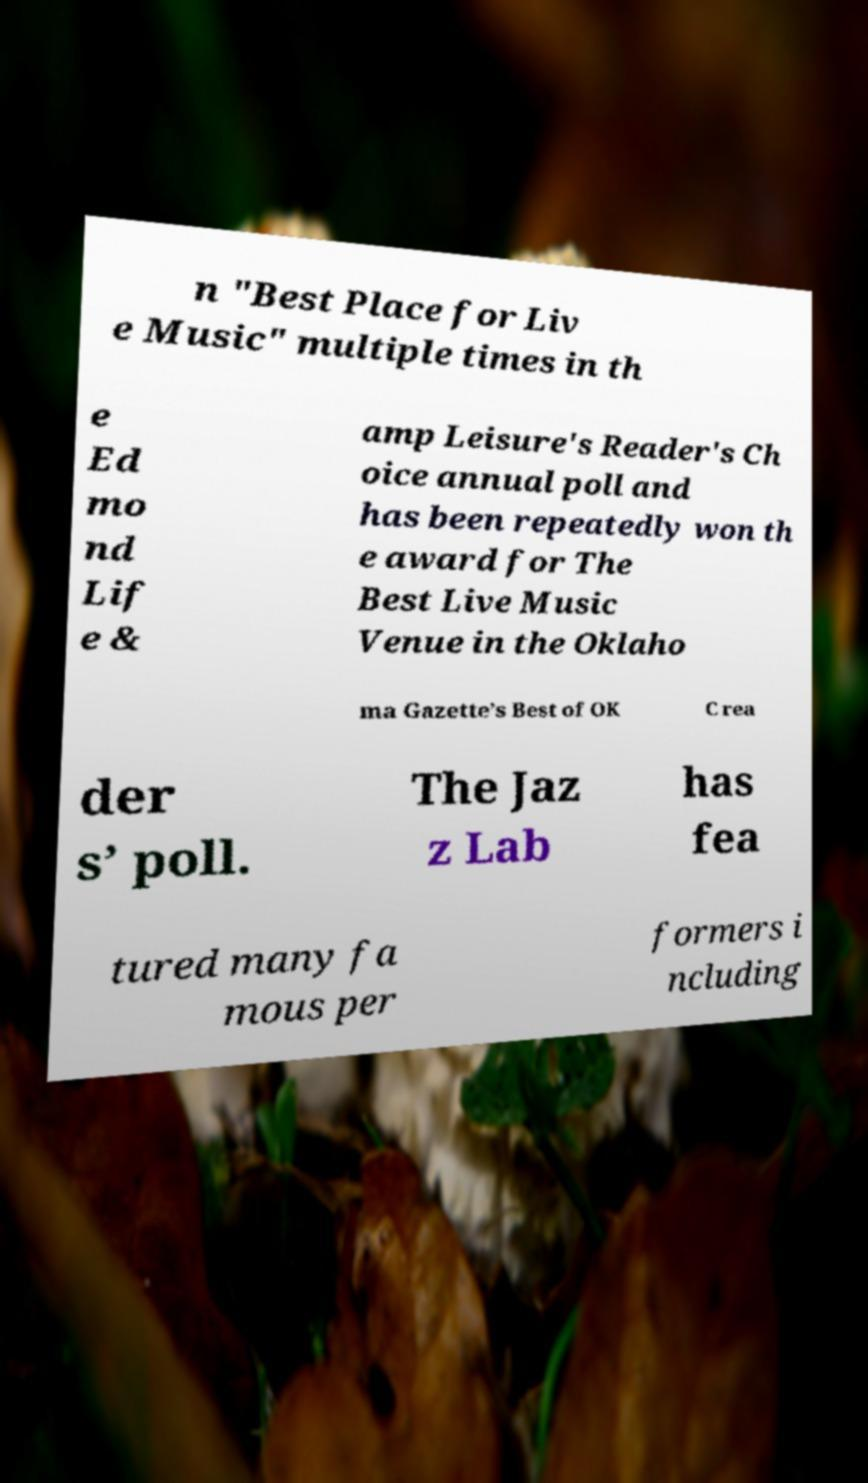Could you extract and type out the text from this image? n "Best Place for Liv e Music" multiple times in th e Ed mo nd Lif e & amp Leisure's Reader's Ch oice annual poll and has been repeatedly won th e award for The Best Live Music Venue in the Oklaho ma Gazette’s Best of OK C rea der s’ poll. The Jaz z Lab has fea tured many fa mous per formers i ncluding 